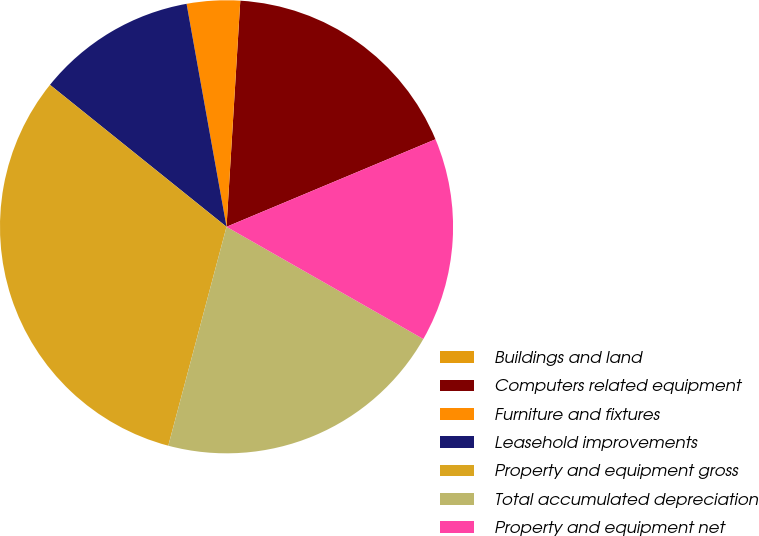Convert chart to OTSL. <chart><loc_0><loc_0><loc_500><loc_500><pie_chart><fcel>Buildings and land<fcel>Computers related equipment<fcel>Furniture and fixtures<fcel>Leasehold improvements<fcel>Property and equipment gross<fcel>Total accumulated depreciation<fcel>Property and equipment net<nl><fcel>0.0%<fcel>17.72%<fcel>3.79%<fcel>11.4%<fcel>31.64%<fcel>20.89%<fcel>14.56%<nl></chart> 